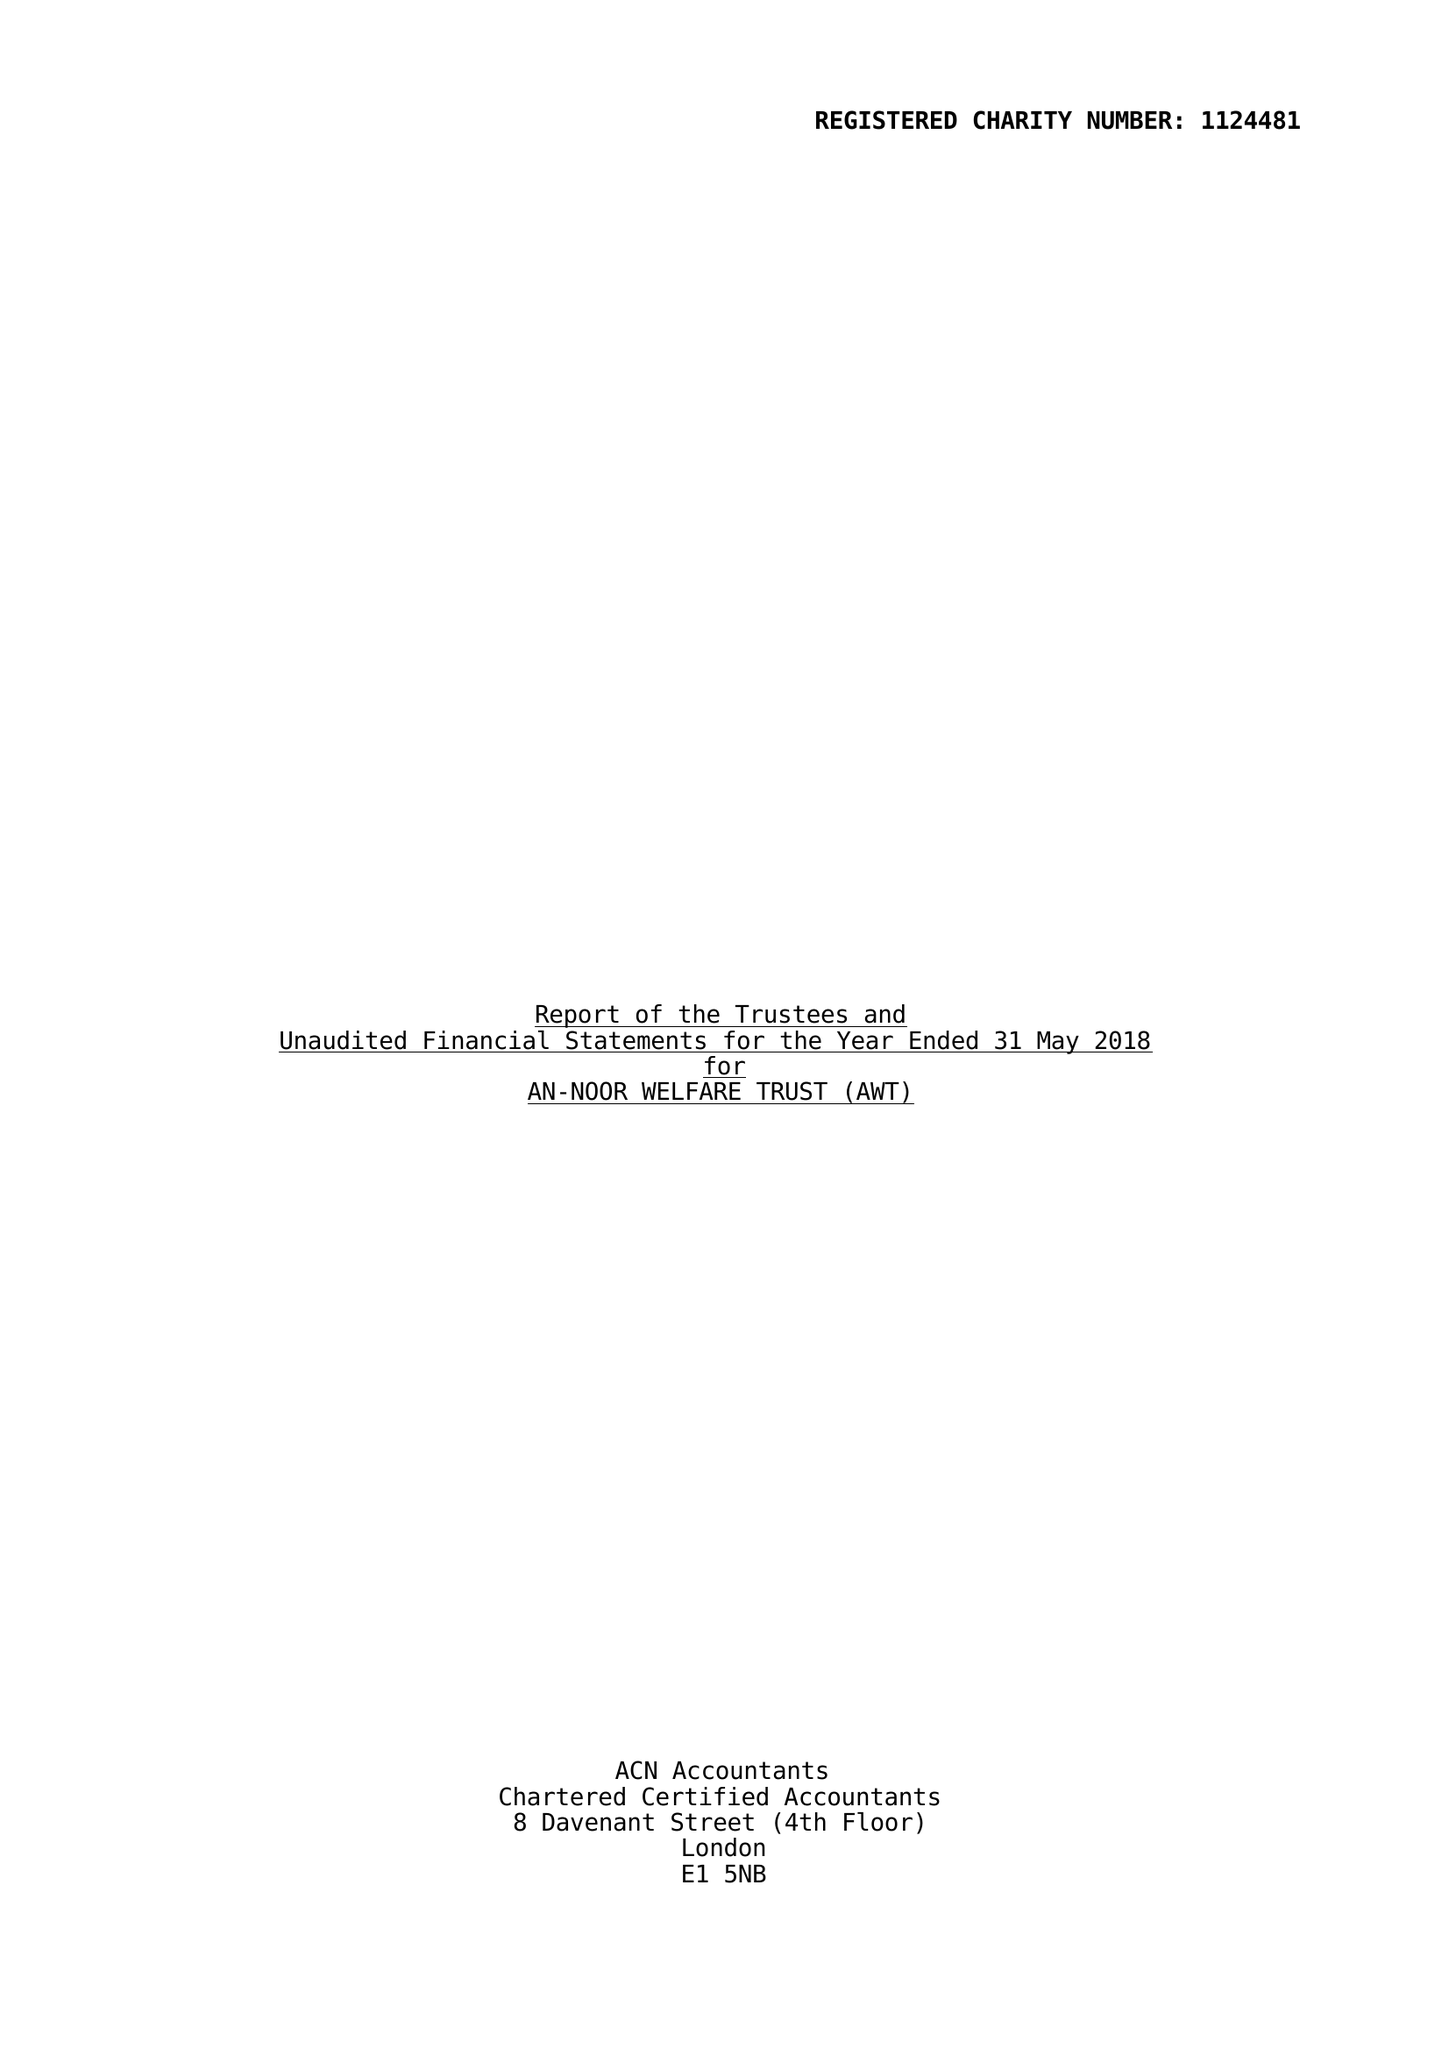What is the value for the report_date?
Answer the question using a single word or phrase. 2018-05-31 